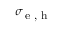<formula> <loc_0><loc_0><loc_500><loc_500>\sigma _ { e , h }</formula> 